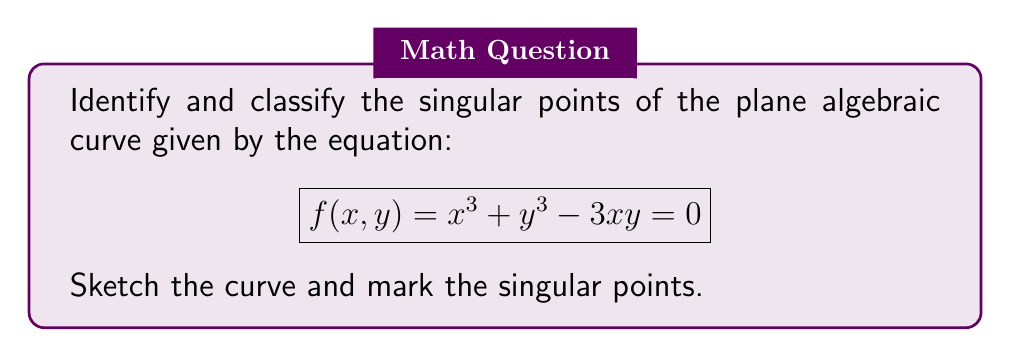What is the answer to this math problem? To identify and classify singular points, we follow these steps:

1) Find partial derivatives:
   $\frac{\partial f}{\partial x} = 3x^2 - 3y$
   $\frac{\partial f}{\partial y} = 3y^2 - 3x$

2) Solve the system of equations:
   $\begin{cases}
   x^3 + y^3 - 3xy = 0 \\
   3x^2 - 3y = 0 \\
   3y^2 - 3x = 0
   \end{cases}$

3) From the last two equations:
   $x^2 = y$ and $y^2 = x$

4) Substituting into each other:
   $x^2 = (x^2)^2 = x^4$
   $x^4 - x^2 = 0$
   $x^2(x^2 - 1) = 0$

5) Solving:
   $x = 0$ or $x = \pm 1$
   If $x = 0$, then $y = 0$
   If $x = \pm 1$, then $y = (\pm 1)^2 = 1$

6) Singular points: $(0,0)$, $(1,1)$, and $(-1,1)$

7) Classification:
   At $(0,0)$: 
   Hessian matrix $H = \begin{bmatrix} 6x & -3 \\ -3 & 6y \end{bmatrix} = \begin{bmatrix} 0 & -3 \\ -3 & 0 \end{bmatrix}$
   $\det(H) = -9 < 0$, so $(0,0)$ is a node.

   At $(1,1)$ and $(-1,1)$:
   $H = \begin{bmatrix} 6 & -3 \\ -3 & 6 \end{bmatrix}$
   $\det(H) = 27 > 0$, so these are cusps.

8) Sketch:
[asy]
import graph;
size(200);
real f(real x, real y) {return x^3 + y^3 - 3x*y;}
draw(contour(f,(-2,-2),(2,2),new real[]{0}));
dot((0,0),red);
dot((1,1),red);
dot((-1,1),red);
label("(0,0)",(0,0),SE);
label("(1,1)",(1,1),NE);
label("(-1,1)",(-1,1),NW);
[/asy]
Answer: Node at $(0,0)$, cusps at $(1,1)$ and $(-1,1)$. 